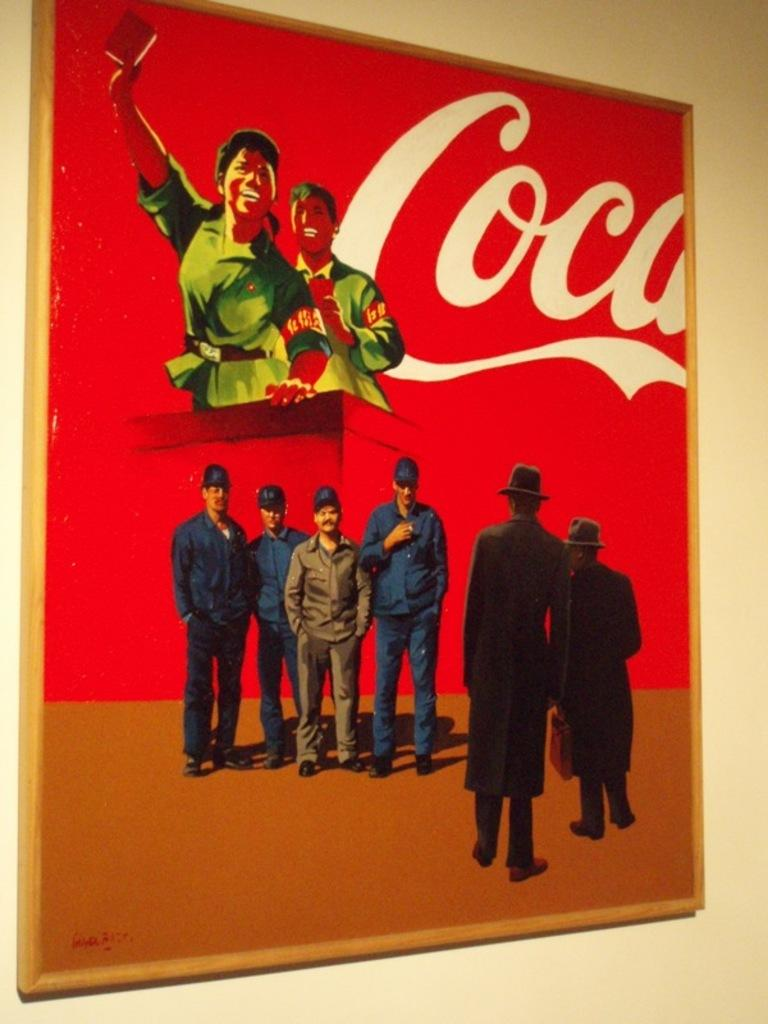What is hanging on the wall in the image? There is a photo frame on the wall. What is inside the photo frame? There are people in the photo frame. Are there any words or letters in the photo frame? Yes, there is text in the photo frame. How is the text positioned within the photo frame? The text is truncated towards the right side of the photo frame. What type of body is visible in the image? There is no body present in the image; it features a photo frame with people in it. Can you tell me how many buckets are in the photo frame? There are no buckets visible in the photo frame; it contains people and text. 